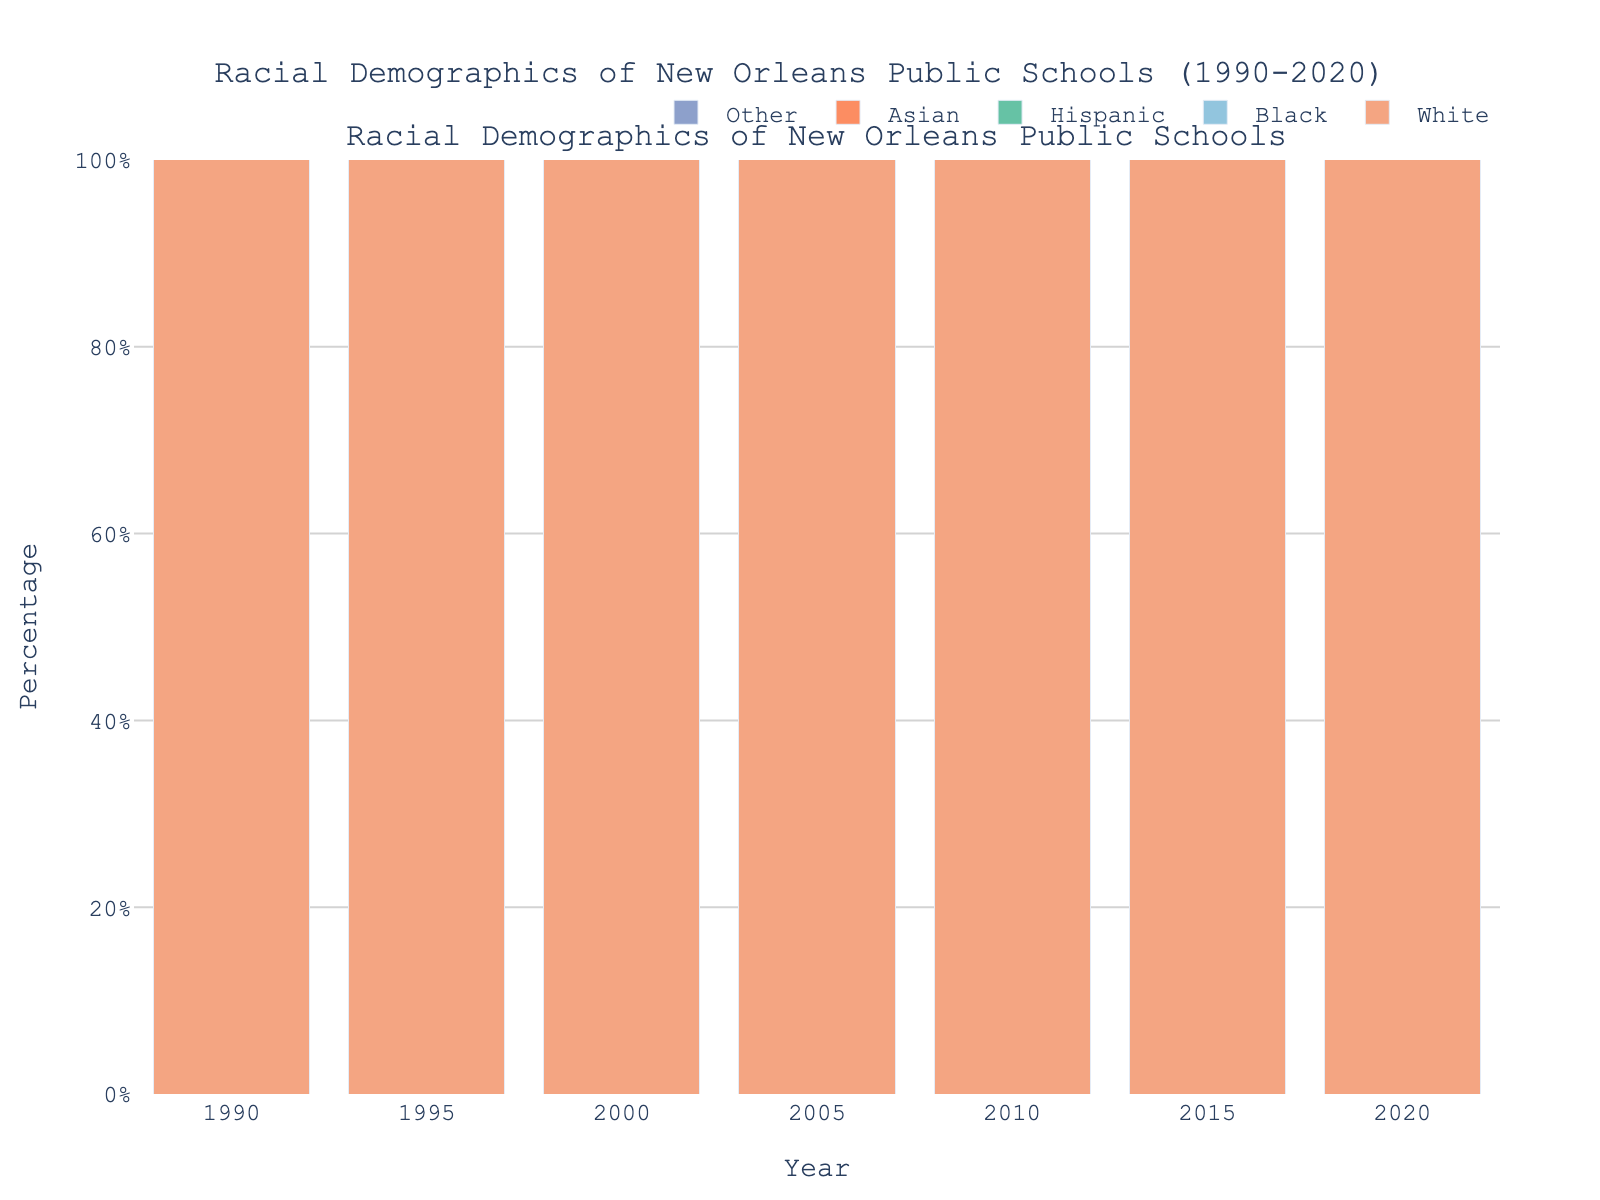What racial group had the highest percentage of students in 1990? The bar for the Black students in 1990 is the tallest, indicating the highest percentage.
Answer: Black How did the percentage of White students change from 1990 to 2020? In 1990, the percentage of White students was 13.5%. By 2020, it had decreased to 9.1%. The change is 13.5% - 9.1% = 4.4%.
Answer: Decreased by 4.4% Which racial group saw the highest increase in percentage from 1990 to 2020? Comparing the initial and final percentages, Hispanic students increased from 1.2% to 8.6%, which is an increase of 8.6% - 1.2% = 7.4%. This is the highest increase among all groups.
Answer: Hispanic In 2015, which racial group had a percentage closest to 10%? In 2015, Hispanic students had a percentage of 6.8%, which is the closest to 10%.
Answer: Hispanic Compare the percentage change of Asian students between 1990 and 2000. In 1990, the percentage was 0.9%. By 2000, it was 1.1%. The change is 1.1% - 0.9% = 0.2%.
Answer: Increased by 0.2% What is the total percentage of students in racial groups other than Black in 2020? Summing all non-Black groups: White (9.1%) + Hispanic (8.6%) + Asian (2.3%) + Other (0.5%) = 20.5%.
Answer: 20.5% Which racial group's percentage remained the smallest throughout the entire period? The "Other" racial group consistently had the smallest percentages in all years.
Answer: Other What is the difference in the percentage of Hispanic students between 2000 and 2010? In 2000, the percentage of Hispanic students was 2.1%. By 2010, it was 5.2%. The difference is 5.2% - 2.1% = 3.1%.
Answer: 3.1% Which year saw the highest percentage of Black students? The highest bar for Black students appears in 2005 with a percentage of 88.3%.
Answer: 2005 How many years did it take for the percentage of White students to drop below 10%? In 2000, the percentage of White students was 9.2%, and it was above 10% in 1995. Thus, it took from 1995 to 2000, which is 5 years.
Answer: 5 years 